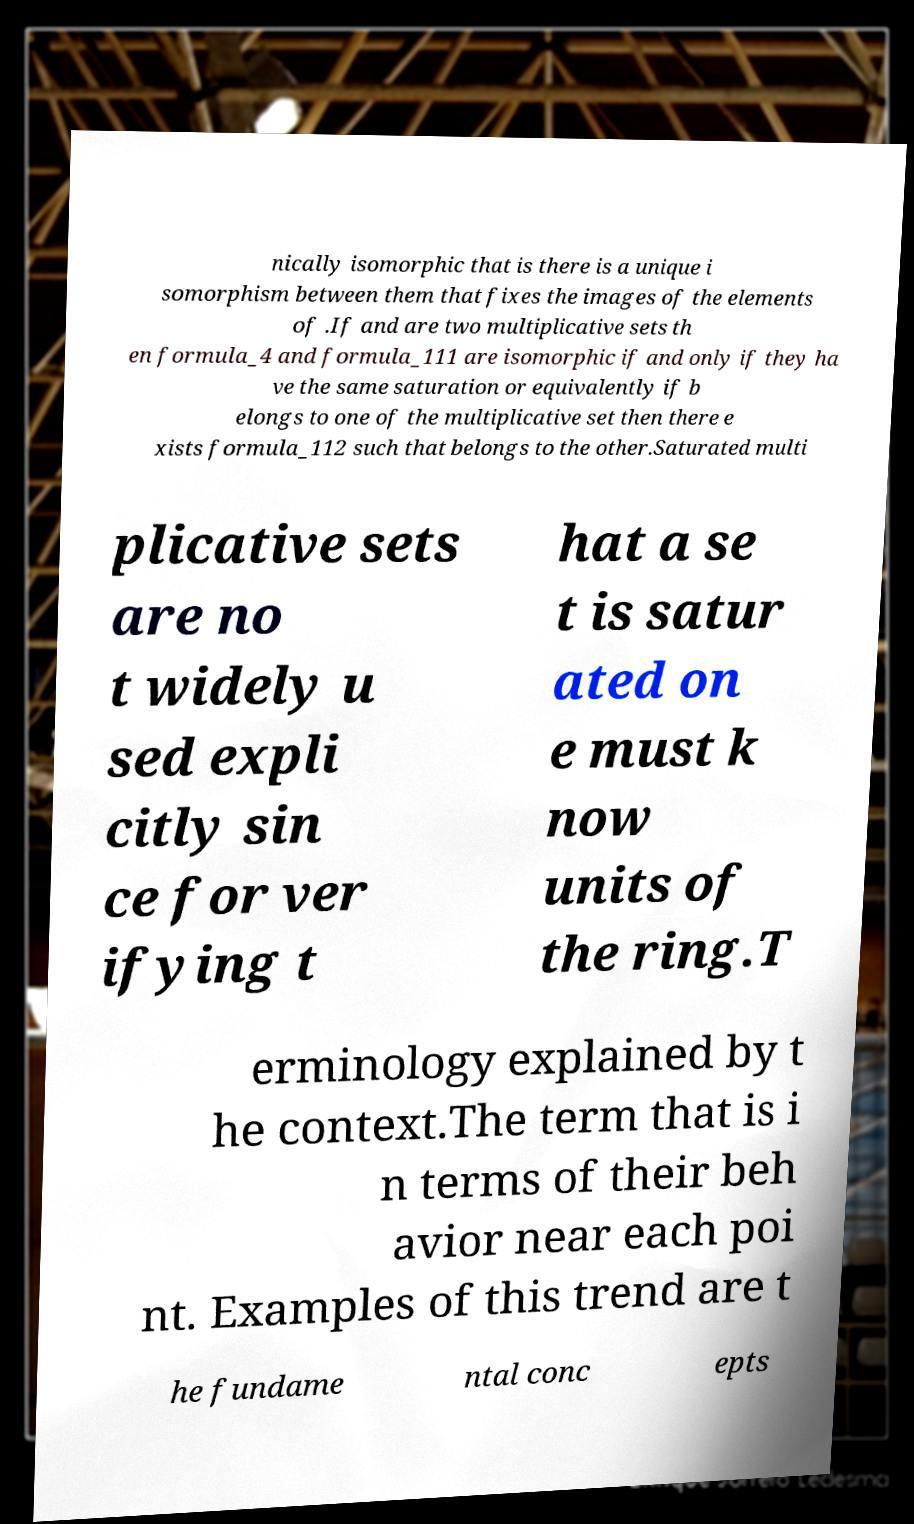What messages or text are displayed in this image? I need them in a readable, typed format. nically isomorphic that is there is a unique i somorphism between them that fixes the images of the elements of .If and are two multiplicative sets th en formula_4 and formula_111 are isomorphic if and only if they ha ve the same saturation or equivalently if b elongs to one of the multiplicative set then there e xists formula_112 such that belongs to the other.Saturated multi plicative sets are no t widely u sed expli citly sin ce for ver ifying t hat a se t is satur ated on e must k now units of the ring.T erminology explained by t he context.The term that is i n terms of their beh avior near each poi nt. Examples of this trend are t he fundame ntal conc epts 